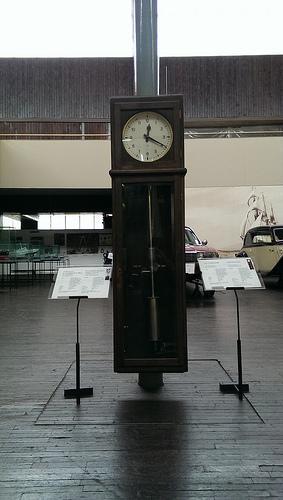How many clocks are visible?
Give a very brief answer. 1. 